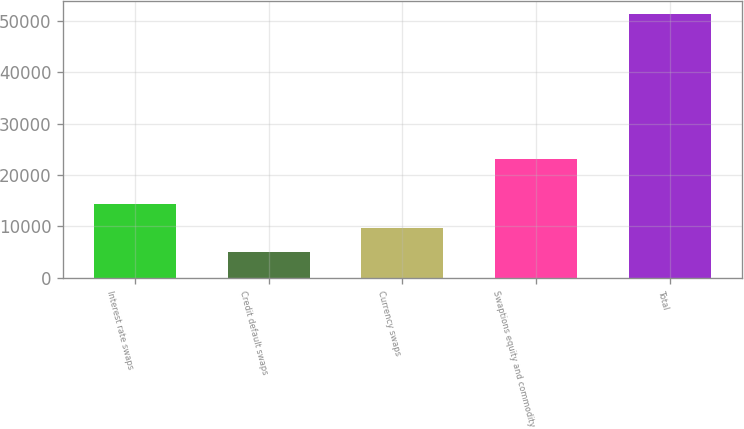Convert chart. <chart><loc_0><loc_0><loc_500><loc_500><bar_chart><fcel>Interest rate swaps<fcel>Credit default swaps<fcel>Currency swaps<fcel>Swaptions equity and commodity<fcel>Total<nl><fcel>14284<fcel>5028<fcel>9656<fcel>23139<fcel>51308<nl></chart> 